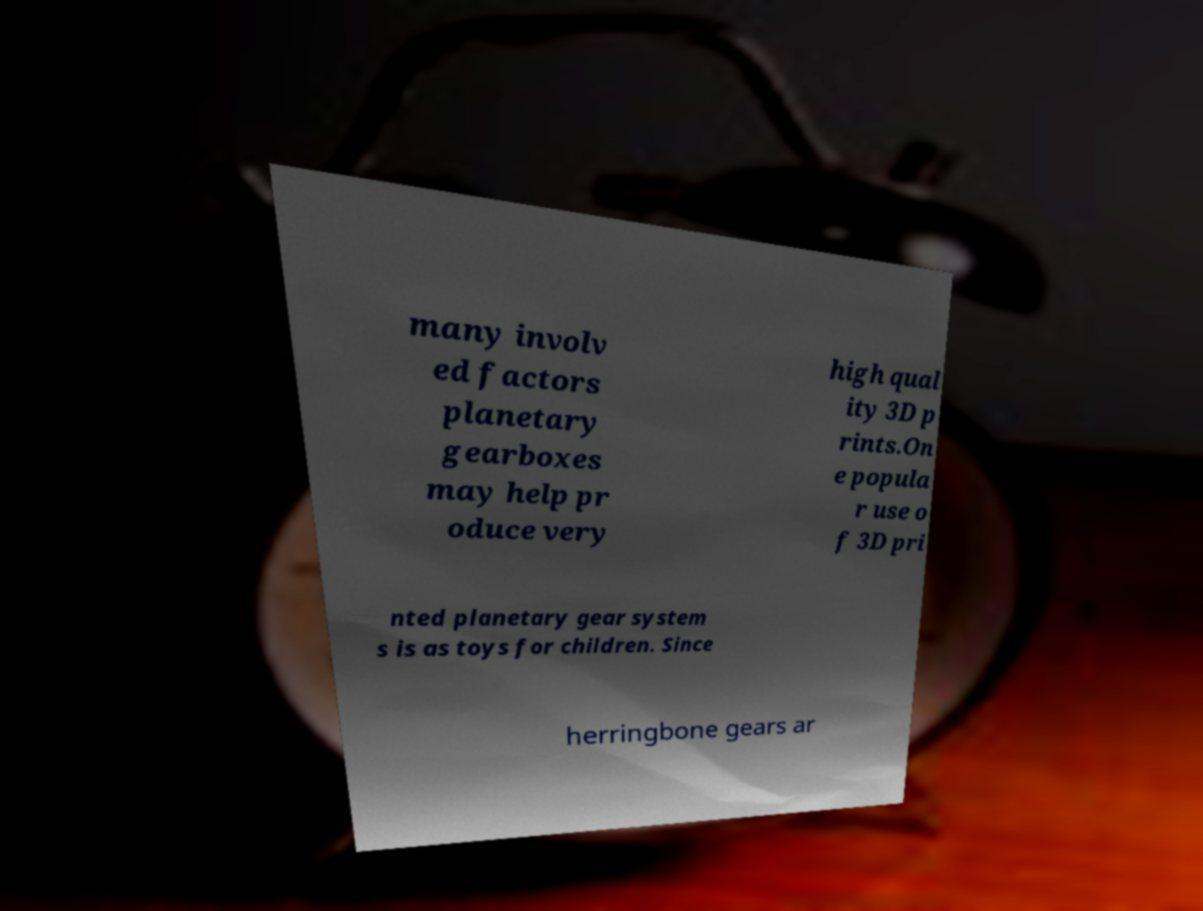There's text embedded in this image that I need extracted. Can you transcribe it verbatim? many involv ed factors planetary gearboxes may help pr oduce very high qual ity 3D p rints.On e popula r use o f 3D pri nted planetary gear system s is as toys for children. Since herringbone gears ar 